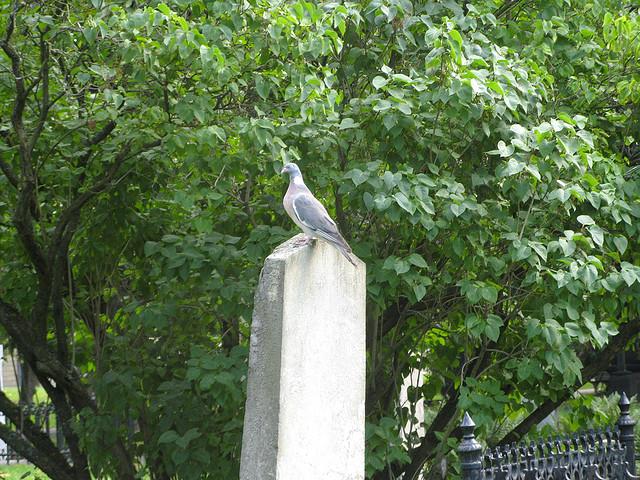At which park is this taking place?
Give a very brief answer. City park. Is the bird lonely?
Be succinct. Yes. What is the bird standing on?
Keep it brief. Tombstone. 